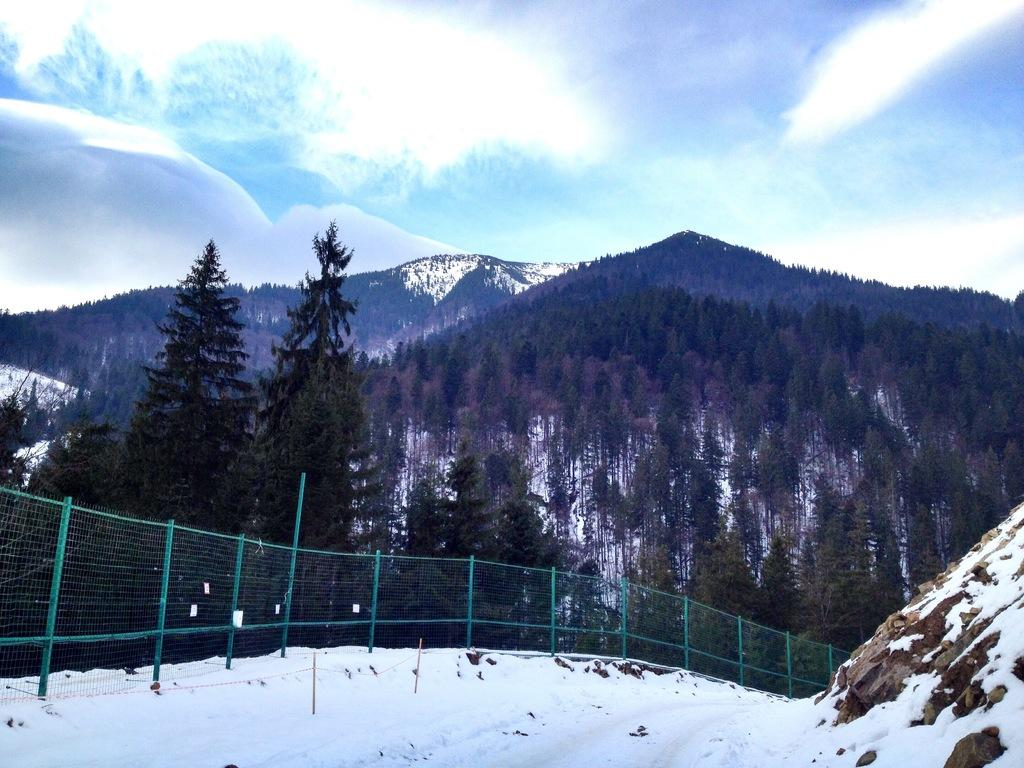What type of weather condition is depicted in the image? The image contains snow, indicating a winter scene. What type of structure can be seen in the image? There is a fence in the image. What type of natural feature is present in the image? Trees are present in the image. What type of large landform can be seen in the image? There is a mountain in the image. What is visible in the background of the image? The sky is visible in the background of the image. What can be seen in the sky in the image? Clouds are present in the sky. What type of truck is visible in the image? There is no truck present in the image. What type of apparatus is being used by the trees in the image? There is no apparatus being used by the trees in the image; they are simply standing in the snow. 